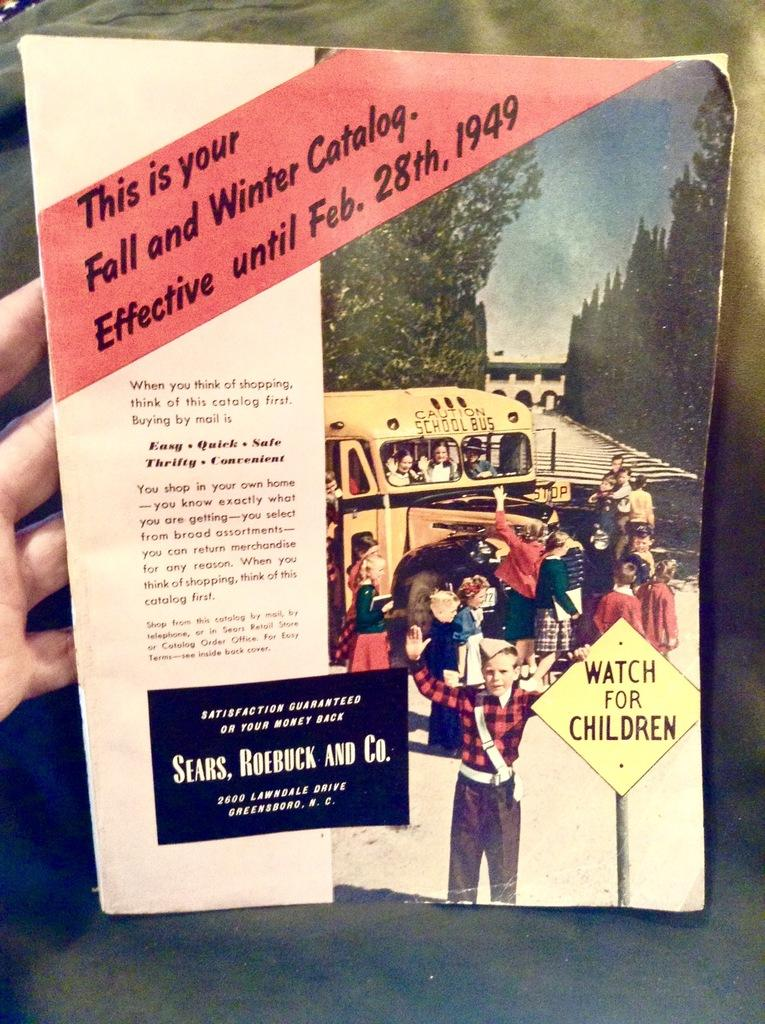What can be seen on the left side of the image? There is a hand of a person on the left side of the image. What is the main object in the middle of the image? There is a book in the middle of the image. What color is the background of the image? The background of the image is green. What direction is the comb pointing in the image? There is no comb present in the image. What type of beam is supporting the book in the image? There is no beam present in the image; the book is resting on a surface. 